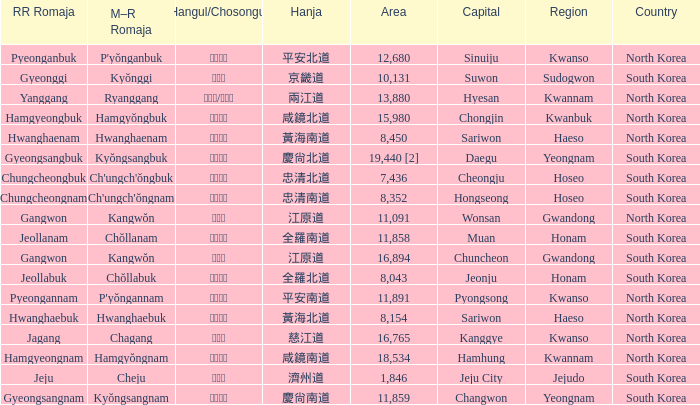What is the M-R Romaja for the province having a capital of Cheongju? Ch'ungch'ŏngbuk. 